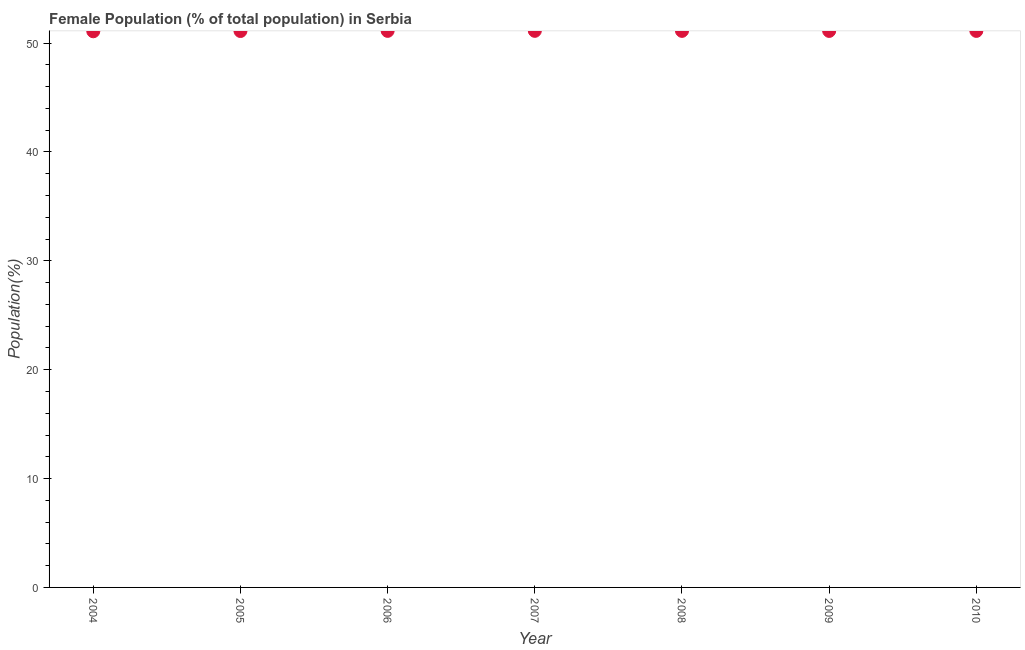What is the female population in 2004?
Provide a short and direct response. 51.09. Across all years, what is the maximum female population?
Your answer should be compact. 51.13. Across all years, what is the minimum female population?
Your response must be concise. 51.09. In which year was the female population maximum?
Your response must be concise. 2007. What is the sum of the female population?
Your answer should be compact. 357.83. What is the difference between the female population in 2004 and 2010?
Offer a terse response. -0.03. What is the average female population per year?
Your answer should be very brief. 51.12. What is the median female population?
Make the answer very short. 51.12. What is the ratio of the female population in 2006 to that in 2008?
Your answer should be very brief. 1. Is the difference between the female population in 2008 and 2010 greater than the difference between any two years?
Your answer should be very brief. No. What is the difference between the highest and the second highest female population?
Offer a very short reply. 0. Is the sum of the female population in 2008 and 2010 greater than the maximum female population across all years?
Ensure brevity in your answer.  Yes. What is the difference between the highest and the lowest female population?
Your response must be concise. 0.04. Does the female population monotonically increase over the years?
Make the answer very short. No. How many dotlines are there?
Offer a terse response. 1. What is the difference between two consecutive major ticks on the Y-axis?
Ensure brevity in your answer.  10. Does the graph contain grids?
Ensure brevity in your answer.  No. What is the title of the graph?
Keep it short and to the point. Female Population (% of total population) in Serbia. What is the label or title of the X-axis?
Make the answer very short. Year. What is the label or title of the Y-axis?
Offer a terse response. Population(%). What is the Population(%) in 2004?
Offer a terse response. 51.09. What is the Population(%) in 2005?
Ensure brevity in your answer.  51.11. What is the Population(%) in 2006?
Make the answer very short. 51.13. What is the Population(%) in 2007?
Your answer should be very brief. 51.13. What is the Population(%) in 2008?
Offer a very short reply. 51.13. What is the Population(%) in 2009?
Your answer should be very brief. 51.12. What is the Population(%) in 2010?
Offer a very short reply. 51.12. What is the difference between the Population(%) in 2004 and 2005?
Offer a very short reply. -0.02. What is the difference between the Population(%) in 2004 and 2006?
Provide a succinct answer. -0.04. What is the difference between the Population(%) in 2004 and 2007?
Make the answer very short. -0.04. What is the difference between the Population(%) in 2004 and 2008?
Your answer should be compact. -0.04. What is the difference between the Population(%) in 2004 and 2009?
Ensure brevity in your answer.  -0.03. What is the difference between the Population(%) in 2004 and 2010?
Provide a succinct answer. -0.03. What is the difference between the Population(%) in 2005 and 2006?
Make the answer very short. -0.01. What is the difference between the Population(%) in 2005 and 2007?
Provide a short and direct response. -0.02. What is the difference between the Population(%) in 2005 and 2008?
Make the answer very short. -0.01. What is the difference between the Population(%) in 2005 and 2009?
Give a very brief answer. -0.01. What is the difference between the Population(%) in 2005 and 2010?
Provide a succinct answer. -0.01. What is the difference between the Population(%) in 2006 and 2007?
Keep it short and to the point. -0. What is the difference between the Population(%) in 2006 and 2008?
Offer a terse response. 0. What is the difference between the Population(%) in 2006 and 2009?
Your answer should be compact. 0. What is the difference between the Population(%) in 2006 and 2010?
Offer a terse response. 0. What is the difference between the Population(%) in 2007 and 2008?
Provide a short and direct response. 0. What is the difference between the Population(%) in 2007 and 2009?
Your answer should be very brief. 0.01. What is the difference between the Population(%) in 2007 and 2010?
Provide a short and direct response. 0.01. What is the difference between the Population(%) in 2008 and 2009?
Provide a short and direct response. 0. What is the difference between the Population(%) in 2008 and 2010?
Your answer should be very brief. 0. What is the difference between the Population(%) in 2009 and 2010?
Your answer should be very brief. -0. What is the ratio of the Population(%) in 2004 to that in 2005?
Ensure brevity in your answer.  1. What is the ratio of the Population(%) in 2004 to that in 2006?
Ensure brevity in your answer.  1. What is the ratio of the Population(%) in 2004 to that in 2007?
Your answer should be very brief. 1. What is the ratio of the Population(%) in 2004 to that in 2009?
Ensure brevity in your answer.  1. What is the ratio of the Population(%) in 2004 to that in 2010?
Offer a very short reply. 1. What is the ratio of the Population(%) in 2005 to that in 2006?
Your response must be concise. 1. What is the ratio of the Population(%) in 2005 to that in 2007?
Offer a very short reply. 1. What is the ratio of the Population(%) in 2005 to that in 2009?
Offer a terse response. 1. What is the ratio of the Population(%) in 2006 to that in 2010?
Ensure brevity in your answer.  1. What is the ratio of the Population(%) in 2007 to that in 2009?
Give a very brief answer. 1. What is the ratio of the Population(%) in 2007 to that in 2010?
Make the answer very short. 1. What is the ratio of the Population(%) in 2008 to that in 2009?
Offer a terse response. 1. What is the ratio of the Population(%) in 2008 to that in 2010?
Make the answer very short. 1. 